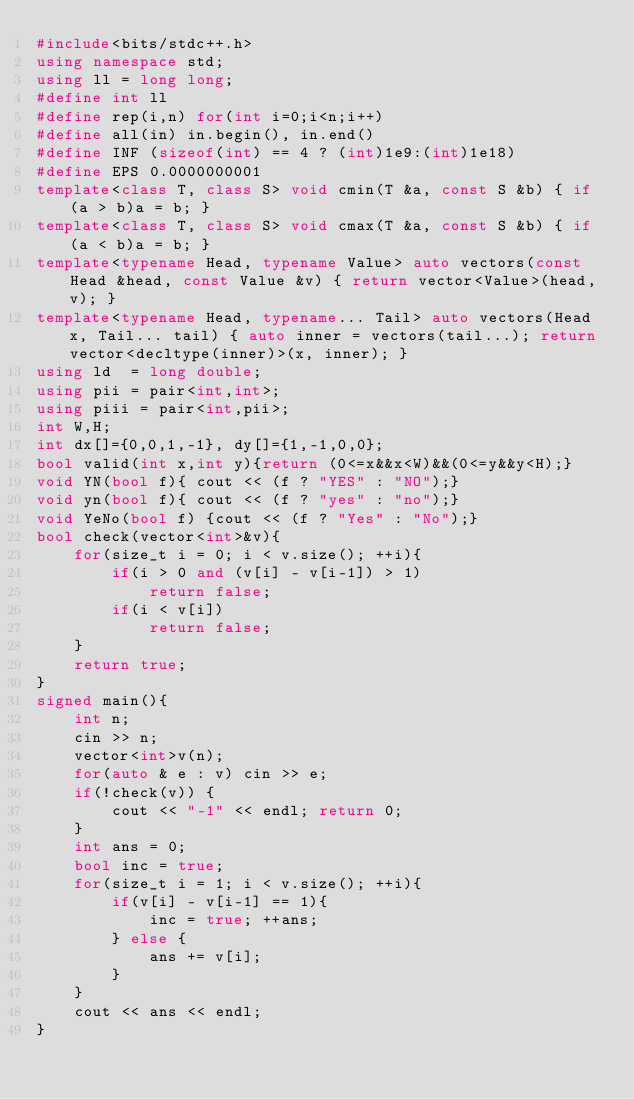Convert code to text. <code><loc_0><loc_0><loc_500><loc_500><_C++_>#include<bits/stdc++.h>
using namespace std;
using ll = long long;
#define int ll
#define rep(i,n) for(int i=0;i<n;i++)
#define all(in) in.begin(), in.end()
#define INF (sizeof(int) == 4 ? (int)1e9:(int)1e18)
#define EPS 0.0000000001
template<class T, class S> void cmin(T &a, const S &b) { if (a > b)a = b; }
template<class T, class S> void cmax(T &a, const S &b) { if (a < b)a = b; }
template<typename Head, typename Value> auto vectors(const Head &head, const Value &v) { return vector<Value>(head, v); }
template<typename Head, typename... Tail> auto vectors(Head x, Tail... tail) { auto inner = vectors(tail...); return vector<decltype(inner)>(x, inner); }
using ld  = long double;
using pii = pair<int,int>;
using piii = pair<int,pii>;
int W,H;
int dx[]={0,0,1,-1}, dy[]={1,-1,0,0};
bool valid(int x,int y){return (0<=x&&x<W)&&(0<=y&&y<H);}
void YN(bool f){ cout << (f ? "YES" : "NO");}
void yn(bool f){ cout << (f ? "yes" : "no");}
void YeNo(bool f) {cout << (f ? "Yes" : "No");}
bool check(vector<int>&v){
    for(size_t i = 0; i < v.size(); ++i){
        if(i > 0 and (v[i] - v[i-1]) > 1)
            return false;
        if(i < v[i])
            return false;
    }
    return true;
}
signed main(){
    int n;
    cin >> n;
    vector<int>v(n);
    for(auto & e : v) cin >> e;
    if(!check(v)) {
        cout << "-1" << endl; return 0;
    }
    int ans = 0;
    bool inc = true;
    for(size_t i = 1; i < v.size(); ++i){
        if(v[i] - v[i-1] == 1){
            inc = true; ++ans;
        } else {
            ans += v[i];
        }
    }
    cout << ans << endl;
}
</code> 